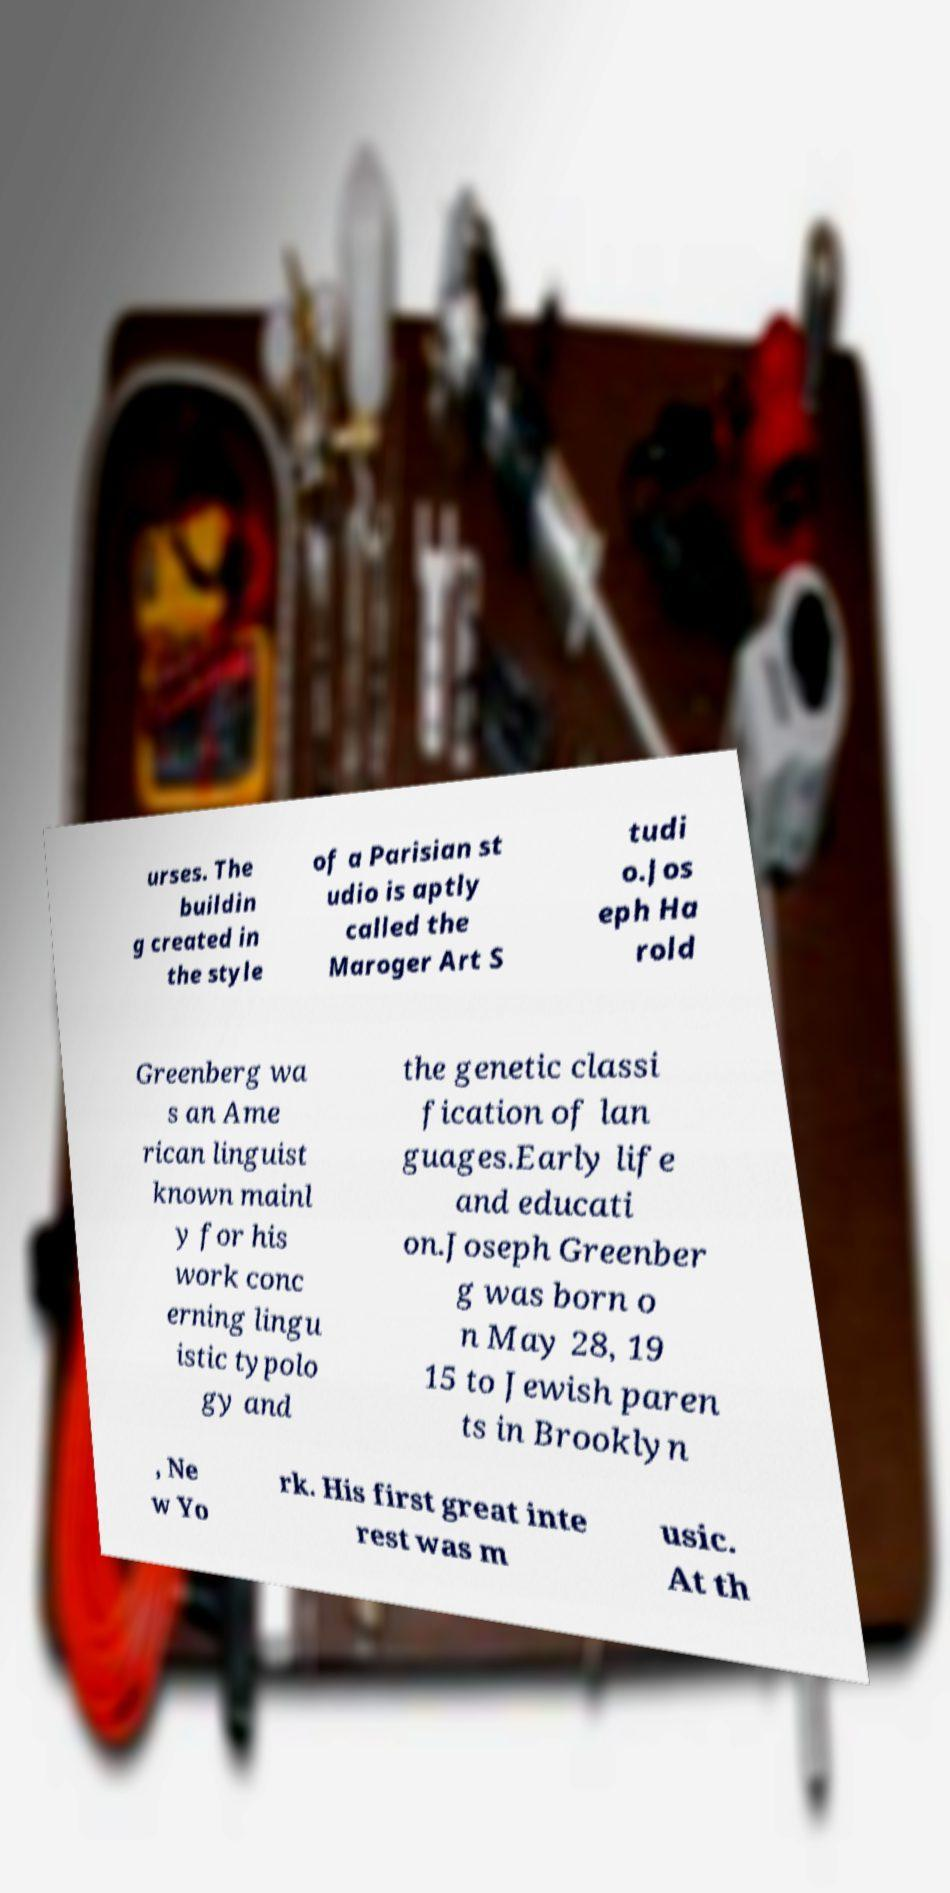I need the written content from this picture converted into text. Can you do that? urses. The buildin g created in the style of a Parisian st udio is aptly called the Maroger Art S tudi o.Jos eph Ha rold Greenberg wa s an Ame rican linguist known mainl y for his work conc erning lingu istic typolo gy and the genetic classi fication of lan guages.Early life and educati on.Joseph Greenber g was born o n May 28, 19 15 to Jewish paren ts in Brooklyn , Ne w Yo rk. His first great inte rest was m usic. At th 